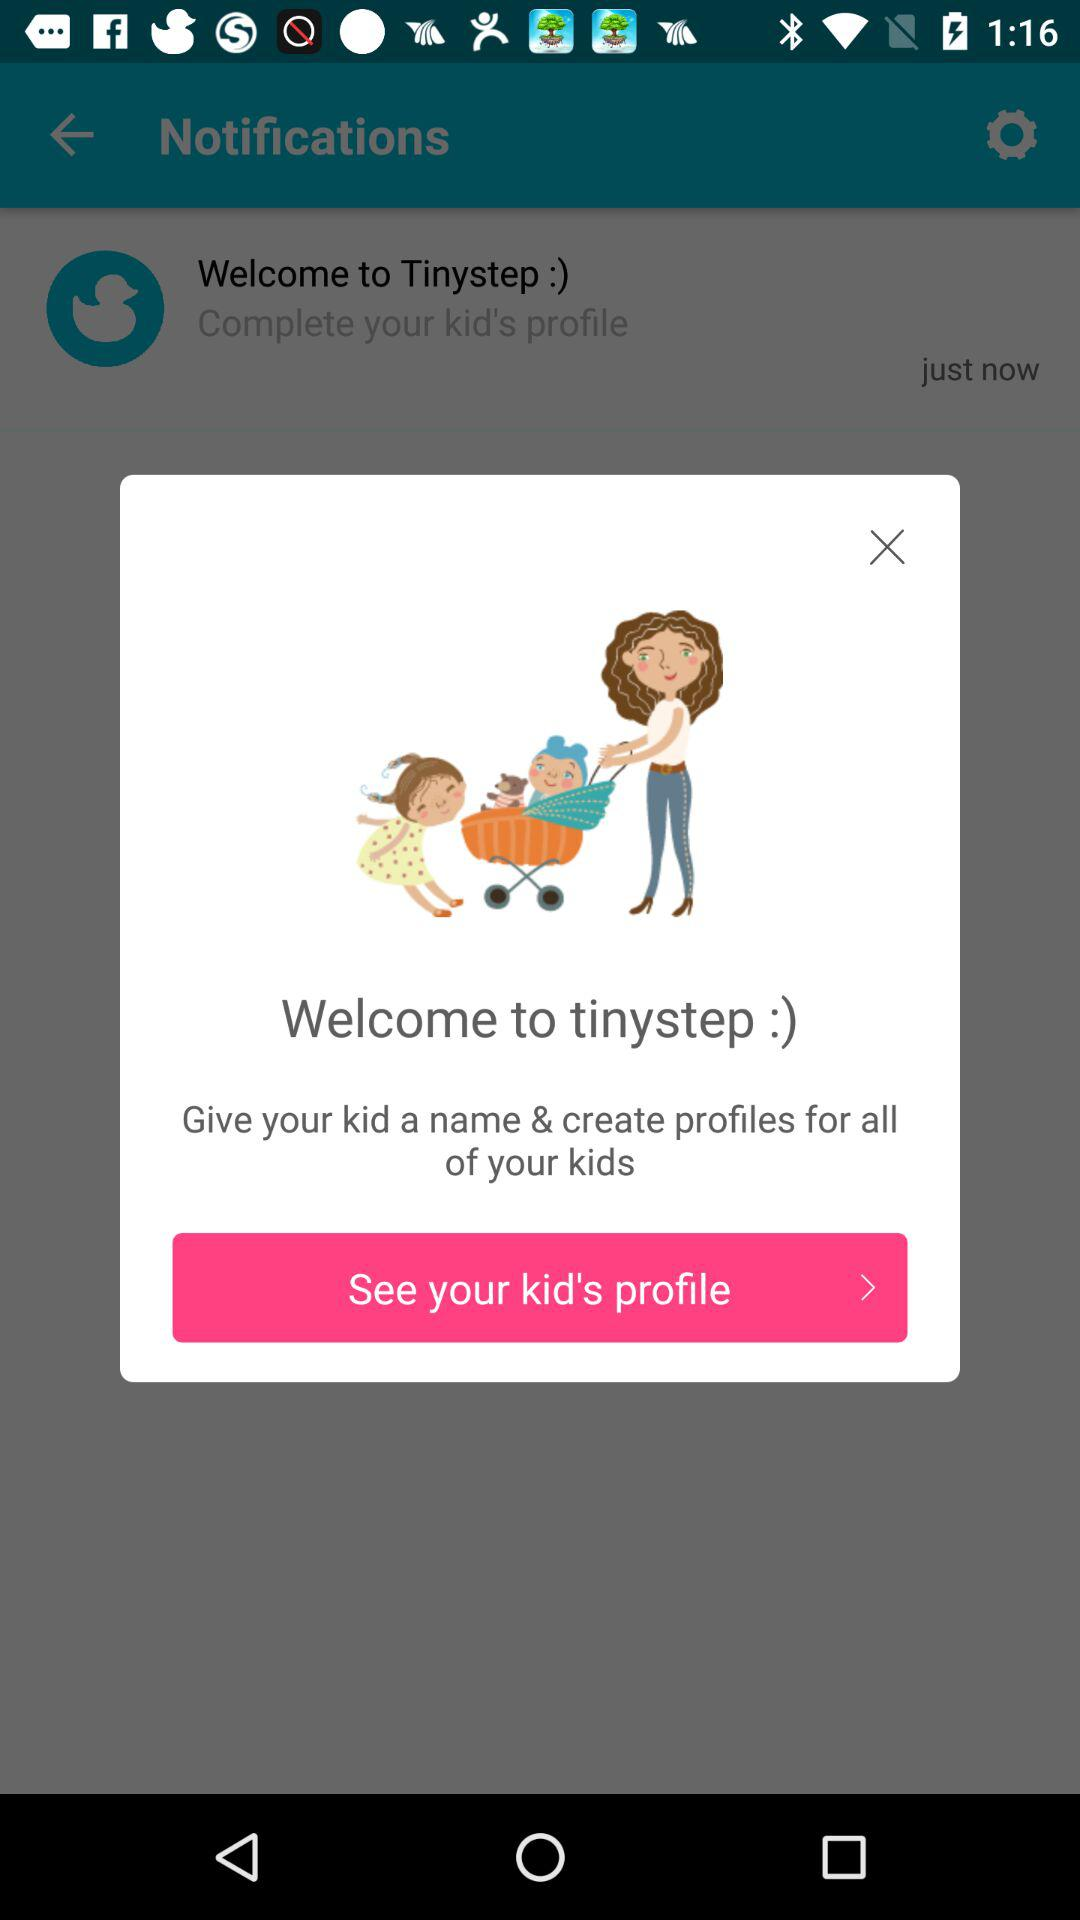What do we need to do to create our kid's profile? You need to give your kid a name and create a profile on tinystep. 